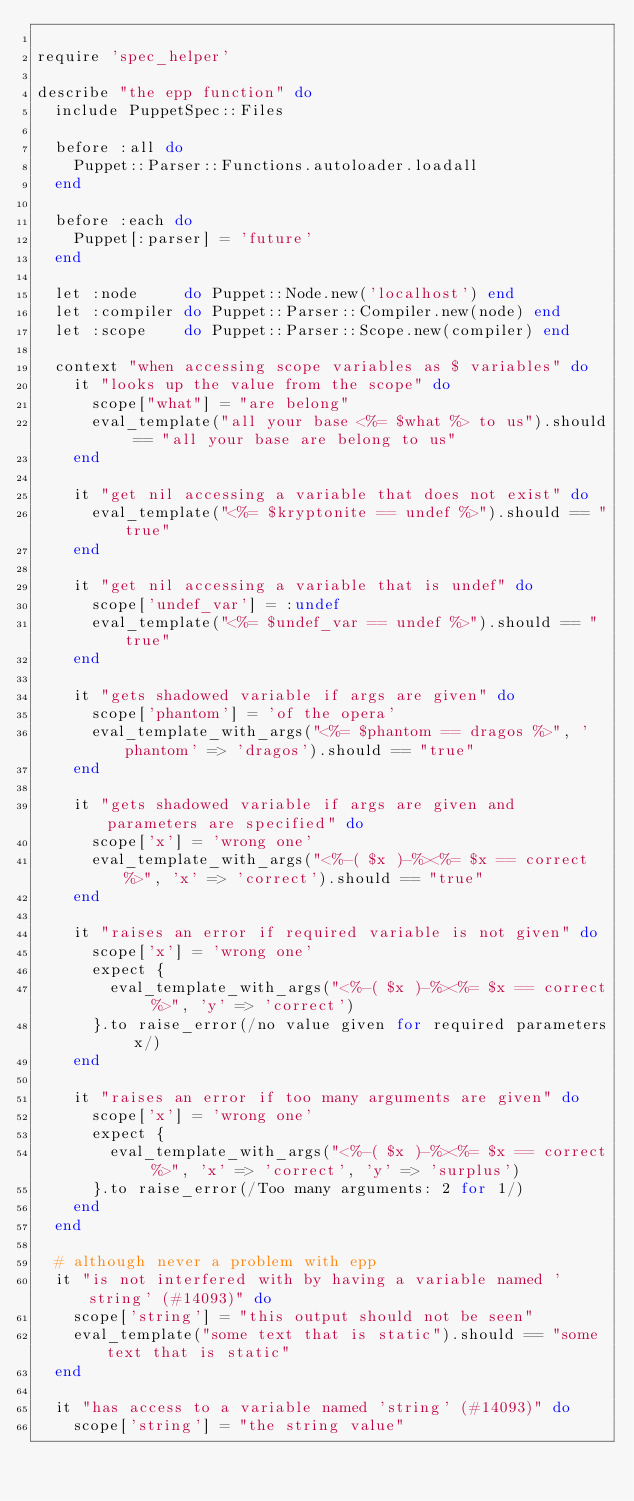<code> <loc_0><loc_0><loc_500><loc_500><_Ruby_>
require 'spec_helper'

describe "the epp function" do
  include PuppetSpec::Files

  before :all do
    Puppet::Parser::Functions.autoloader.loadall
  end

  before :each do
    Puppet[:parser] = 'future'
  end

  let :node     do Puppet::Node.new('localhost') end
  let :compiler do Puppet::Parser::Compiler.new(node) end
  let :scope    do Puppet::Parser::Scope.new(compiler) end

  context "when accessing scope variables as $ variables" do
    it "looks up the value from the scope" do
      scope["what"] = "are belong"
      eval_template("all your base <%= $what %> to us").should == "all your base are belong to us"
    end

    it "get nil accessing a variable that does not exist" do
      eval_template("<%= $kryptonite == undef %>").should == "true"
    end

    it "get nil accessing a variable that is undef" do
      scope['undef_var'] = :undef
      eval_template("<%= $undef_var == undef %>").should == "true"
    end

    it "gets shadowed variable if args are given" do
      scope['phantom'] = 'of the opera'
      eval_template_with_args("<%= $phantom == dragos %>", 'phantom' => 'dragos').should == "true"
    end

    it "gets shadowed variable if args are given and parameters are specified" do
      scope['x'] = 'wrong one'
      eval_template_with_args("<%-( $x )-%><%= $x == correct %>", 'x' => 'correct').should == "true"
    end

    it "raises an error if required variable is not given" do
      scope['x'] = 'wrong one'
      expect {
        eval_template_with_args("<%-( $x )-%><%= $x == correct %>", 'y' => 'correct')
      }.to raise_error(/no value given for required parameters x/)
    end

    it "raises an error if too many arguments are given" do
      scope['x'] = 'wrong one'
      expect {
        eval_template_with_args("<%-( $x )-%><%= $x == correct %>", 'x' => 'correct', 'y' => 'surplus')
      }.to raise_error(/Too many arguments: 2 for 1/)
    end
  end

  # although never a problem with epp
  it "is not interfered with by having a variable named 'string' (#14093)" do
    scope['string'] = "this output should not be seen"
    eval_template("some text that is static").should == "some text that is static"
  end

  it "has access to a variable named 'string' (#14093)" do
    scope['string'] = "the string value"</code> 